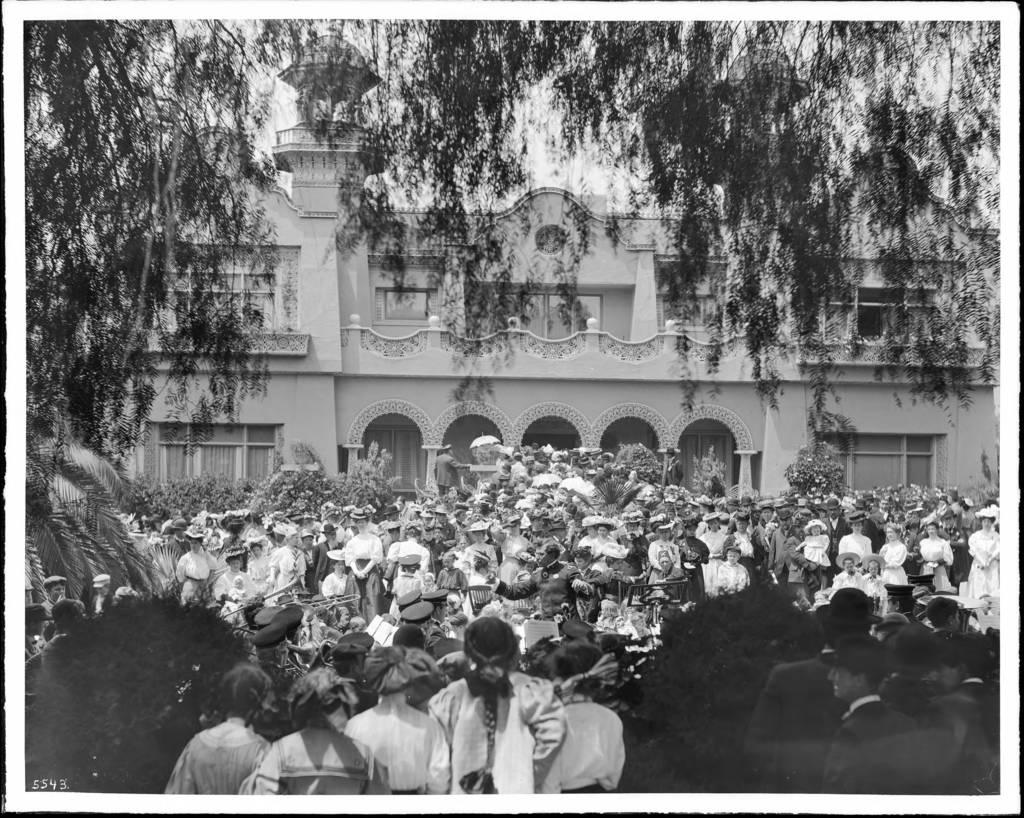What is the color scheme of the image? The image is black and white. What can be seen in the background of the image? There is a building in the image. What is located in front of the building? There are plants and people in front of the building. What type of vegetation is visible in the image? There is a tree visible in the image. Can you tell me how many rays are touching the building in the image? There are no rays visible in the image, so it is not possible to determine how many might be touching the building. 